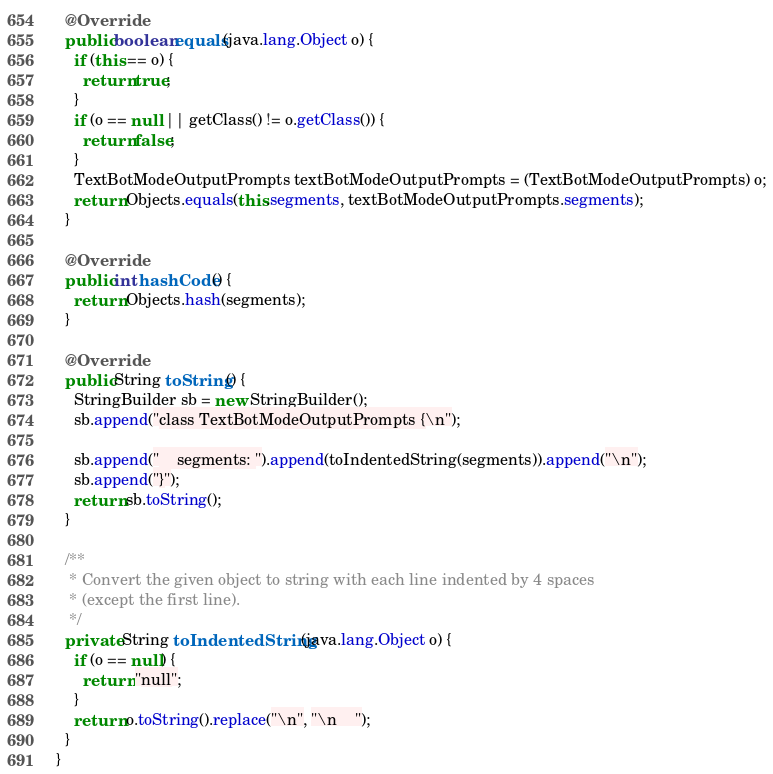Convert code to text. <code><loc_0><loc_0><loc_500><loc_500><_Java_>
  @Override
  public boolean equals(java.lang.Object o) {
    if (this == o) {
      return true;
    }
    if (o == null || getClass() != o.getClass()) {
      return false;
    }
    TextBotModeOutputPrompts textBotModeOutputPrompts = (TextBotModeOutputPrompts) o;
    return Objects.equals(this.segments, textBotModeOutputPrompts.segments);
  }

  @Override
  public int hashCode() {
    return Objects.hash(segments);
  }

  @Override
  public String toString() {
    StringBuilder sb = new StringBuilder();
    sb.append("class TextBotModeOutputPrompts {\n");
    
    sb.append("    segments: ").append(toIndentedString(segments)).append("\n");
    sb.append("}");
    return sb.toString();
  }

  /**
   * Convert the given object to string with each line indented by 4 spaces
   * (except the first line).
   */
  private String toIndentedString(java.lang.Object o) {
    if (o == null) {
      return "null";
    }
    return o.toString().replace("\n", "\n    ");
  }
}

</code> 